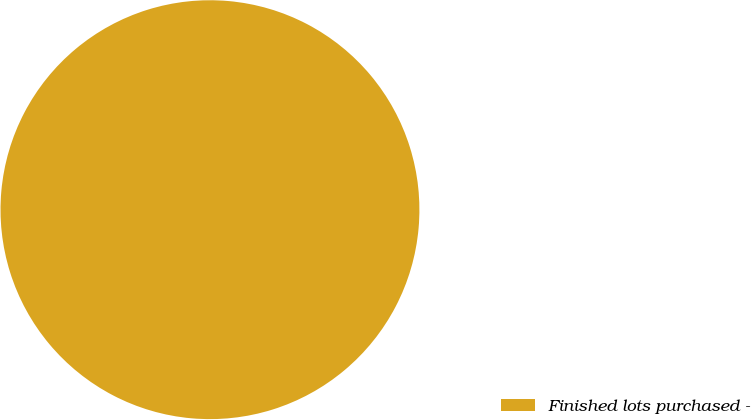Convert chart to OTSL. <chart><loc_0><loc_0><loc_500><loc_500><pie_chart><fcel>Finished lots purchased -<nl><fcel>100.0%<nl></chart> 